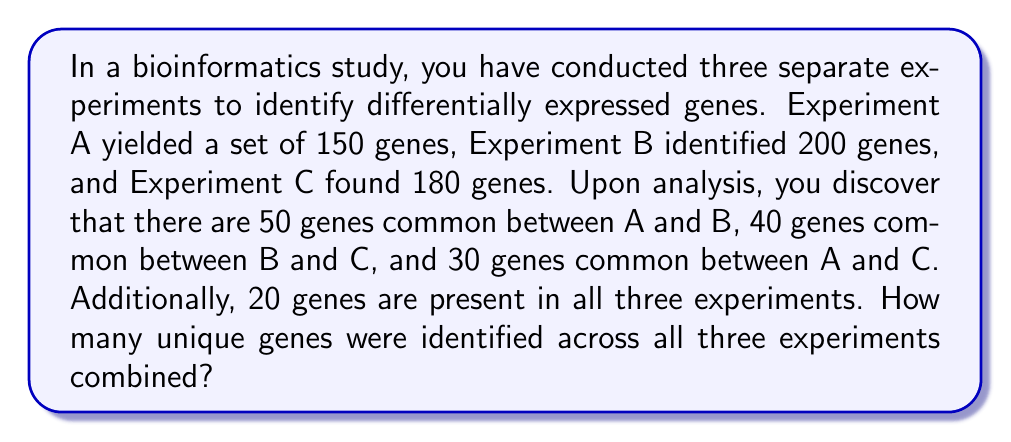Show me your answer to this math problem. To solve this problem, we can use the principle of inclusion-exclusion from set theory. Let's break it down step-by-step:

1. Define our sets:
   $A$ = genes from Experiment A
   $B$ = genes from Experiment B
   $C$ = genes from Experiment C

2. Given information:
   $|A| = 150$, $|B| = 200$, $|C| = 180$
   $|A \cap B| = 50$, $|B \cap C| = 40$, $|A \cap C| = 30$
   $|A \cap B \cap C| = 20$

3. The formula for the union of three sets is:

   $$|A \cup B \cup C| = |A| + |B| + |C| - |A \cap B| - |B \cap C| - |A \cap C| + |A \cap B \cap C|$$

4. Substituting our values:

   $$|A \cup B \cup C| = 150 + 200 + 180 - 50 - 40 - 30 + 20$$

5. Calculating:
   
   $$|A \cup B \cup C| = 530 - 120 + 20 = 430$$

This result represents the total number of unique genes identified across all three experiments.
Answer: 430 unique genes 